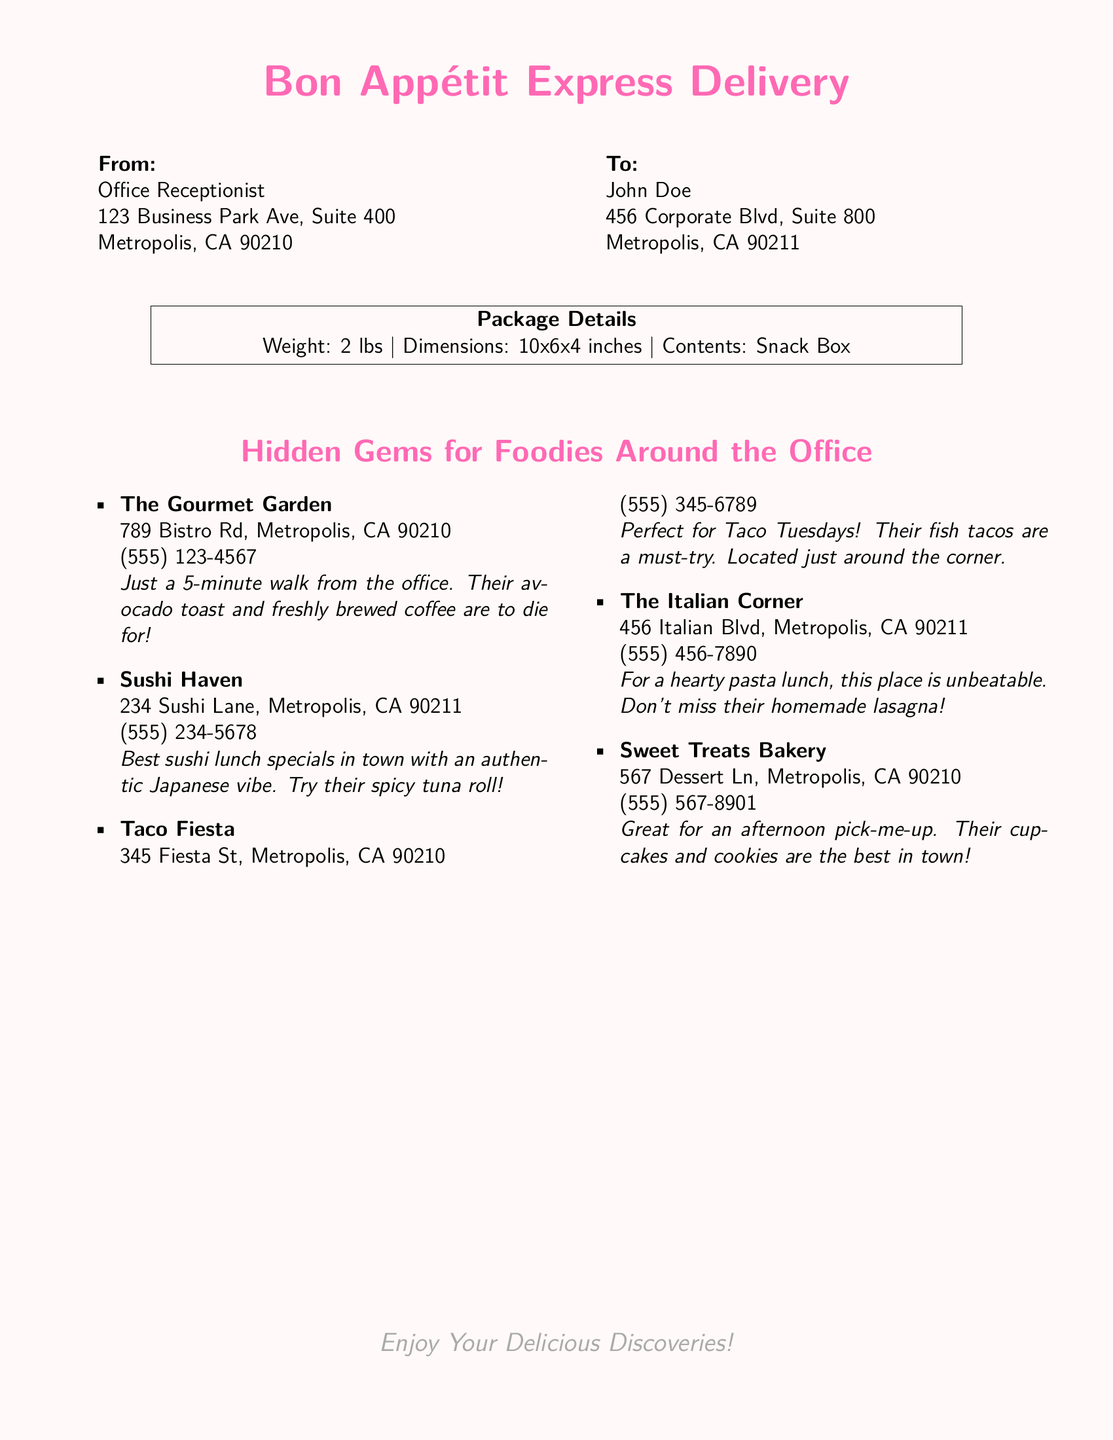what is the sender's title? The sender's title is listed at the top of the shipping label, which is "Office Receptionist."
Answer: Office Receptionist who is the recipient? The recipient's name is the first line in the "To" section of the document, which is "John Doe."
Answer: John Doe what is the weight of the package? The weight of the package is specified in the "Package Details" section, which states it is "2 lbs."
Answer: 2 lbs how many different food places are listed? The document lists five different food places, seen in the "Hidden Gems for Foodies Around the Office" section.
Answer: 5 what is the phone number for The Gourmet Garden? The document provides the phone number for The Gourmet Garden, which is "(555) 123-4567."
Answer: (555) 123-4567 which food place specializes in sushi? The food place that specializes in sushi is mentioned in the food list, which is "Sushi Haven."
Answer: Sushi Haven where is Taco Fiesta located? The location of Taco Fiesta is mentioned in the document, which is "345 Fiesta St, Metropolis, CA 90210."
Answer: 345 Fiesta St, Metropolis, CA 90210 what is the color of the page background? The color of the page background is indicated in the document as "pink."
Answer: pink what is the theme of the shipping label? The theme is indicated in the document's title, which is "Bon Appétit Express Delivery."
Answer: Bon Appétit Express Delivery 